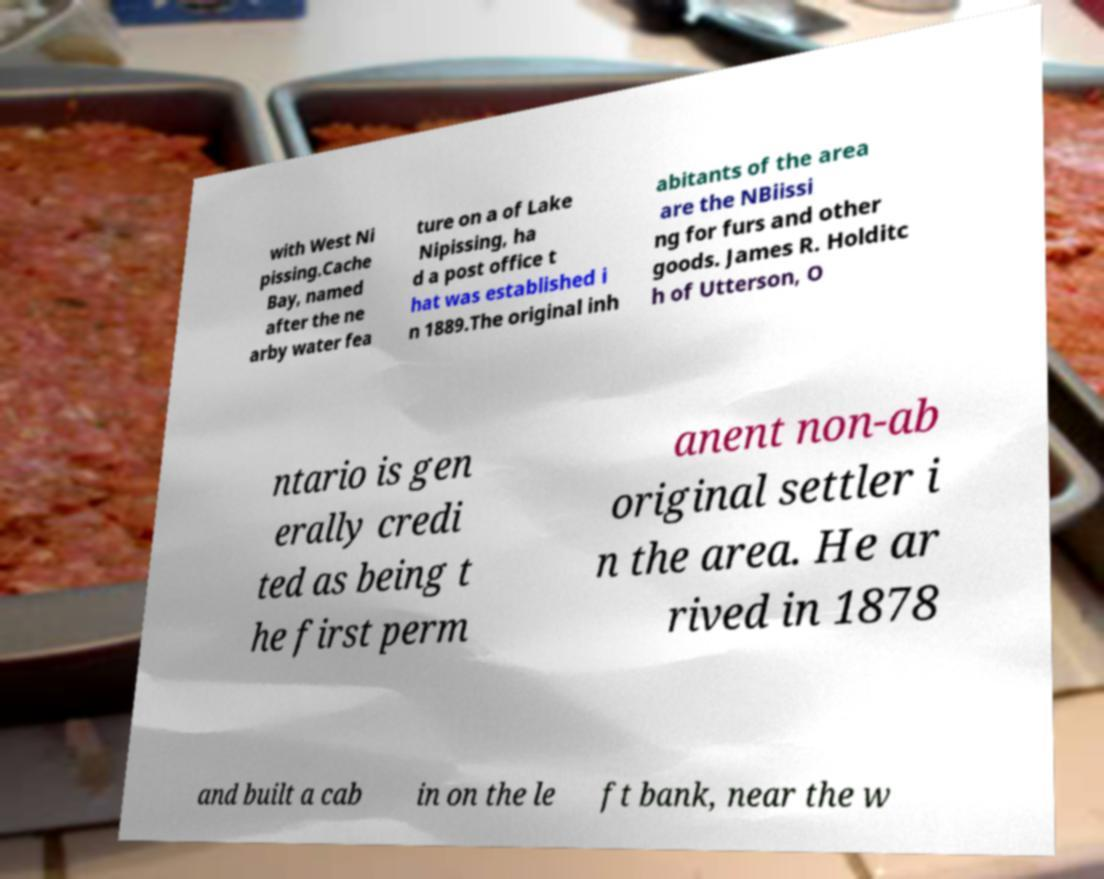What historical event mentioned on this document occurred in 1889? In 1889, a post office was established in Cache Bay, located near Lake Nipissing. 